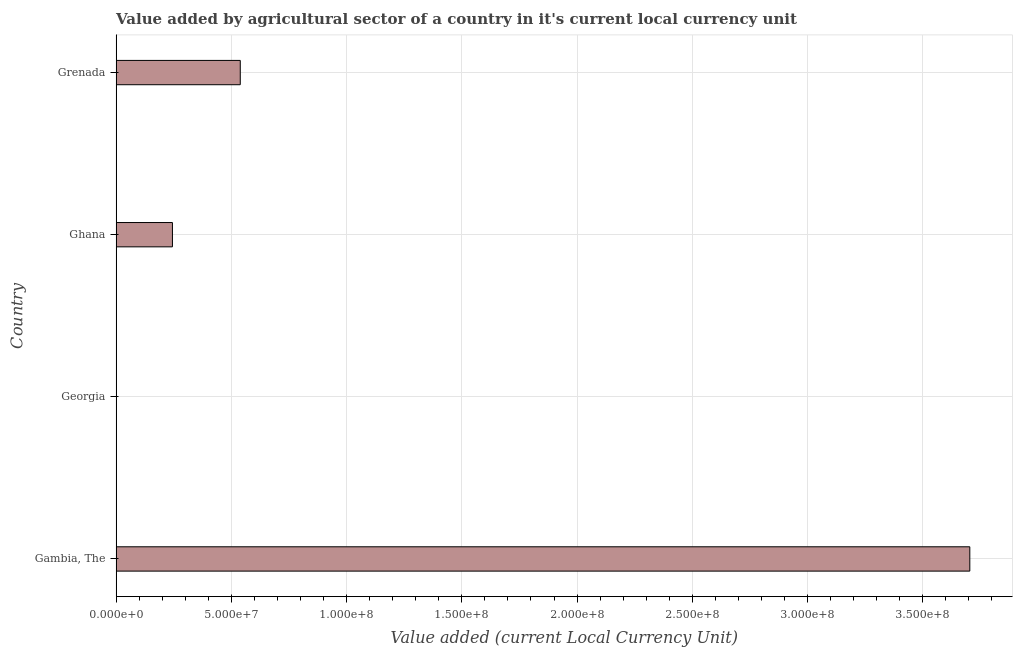Does the graph contain any zero values?
Give a very brief answer. No. Does the graph contain grids?
Your answer should be very brief. Yes. What is the title of the graph?
Provide a succinct answer. Value added by agricultural sector of a country in it's current local currency unit. What is the label or title of the X-axis?
Keep it short and to the point. Value added (current Local Currency Unit). What is the label or title of the Y-axis?
Make the answer very short. Country. What is the value added by agriculture sector in Grenada?
Provide a succinct answer. 5.39e+07. Across all countries, what is the maximum value added by agriculture sector?
Your answer should be compact. 3.70e+08. Across all countries, what is the minimum value added by agriculture sector?
Offer a terse response. 3400. In which country was the value added by agriculture sector maximum?
Give a very brief answer. Gambia, The. In which country was the value added by agriculture sector minimum?
Offer a terse response. Georgia. What is the sum of the value added by agriculture sector?
Ensure brevity in your answer.  4.49e+08. What is the difference between the value added by agriculture sector in Ghana and Grenada?
Offer a terse response. -2.94e+07. What is the average value added by agriculture sector per country?
Keep it short and to the point. 1.12e+08. What is the median value added by agriculture sector?
Your response must be concise. 3.91e+07. In how many countries, is the value added by agriculture sector greater than 230000000 LCU?
Your answer should be very brief. 1. What is the ratio of the value added by agriculture sector in Ghana to that in Grenada?
Provide a succinct answer. 0.45. What is the difference between the highest and the second highest value added by agriculture sector?
Ensure brevity in your answer.  3.17e+08. Is the sum of the value added by agriculture sector in Gambia, The and Georgia greater than the maximum value added by agriculture sector across all countries?
Give a very brief answer. Yes. What is the difference between the highest and the lowest value added by agriculture sector?
Make the answer very short. 3.70e+08. How many bars are there?
Provide a succinct answer. 4. Are the values on the major ticks of X-axis written in scientific E-notation?
Offer a very short reply. Yes. What is the Value added (current Local Currency Unit) in Gambia, The?
Keep it short and to the point. 3.70e+08. What is the Value added (current Local Currency Unit) of Georgia?
Offer a very short reply. 3400. What is the Value added (current Local Currency Unit) in Ghana?
Make the answer very short. 2.44e+07. What is the Value added (current Local Currency Unit) of Grenada?
Keep it short and to the point. 5.39e+07. What is the difference between the Value added (current Local Currency Unit) in Gambia, The and Georgia?
Ensure brevity in your answer.  3.70e+08. What is the difference between the Value added (current Local Currency Unit) in Gambia, The and Ghana?
Provide a succinct answer. 3.46e+08. What is the difference between the Value added (current Local Currency Unit) in Gambia, The and Grenada?
Ensure brevity in your answer.  3.17e+08. What is the difference between the Value added (current Local Currency Unit) in Georgia and Ghana?
Provide a succinct answer. -2.44e+07. What is the difference between the Value added (current Local Currency Unit) in Georgia and Grenada?
Provide a succinct answer. -5.39e+07. What is the difference between the Value added (current Local Currency Unit) in Ghana and Grenada?
Give a very brief answer. -2.94e+07. What is the ratio of the Value added (current Local Currency Unit) in Gambia, The to that in Georgia?
Give a very brief answer. 1.09e+05. What is the ratio of the Value added (current Local Currency Unit) in Gambia, The to that in Ghana?
Provide a short and direct response. 15.16. What is the ratio of the Value added (current Local Currency Unit) in Gambia, The to that in Grenada?
Provide a succinct answer. 6.88. What is the ratio of the Value added (current Local Currency Unit) in Georgia to that in Ghana?
Provide a short and direct response. 0. What is the ratio of the Value added (current Local Currency Unit) in Ghana to that in Grenada?
Your answer should be compact. 0.45. 